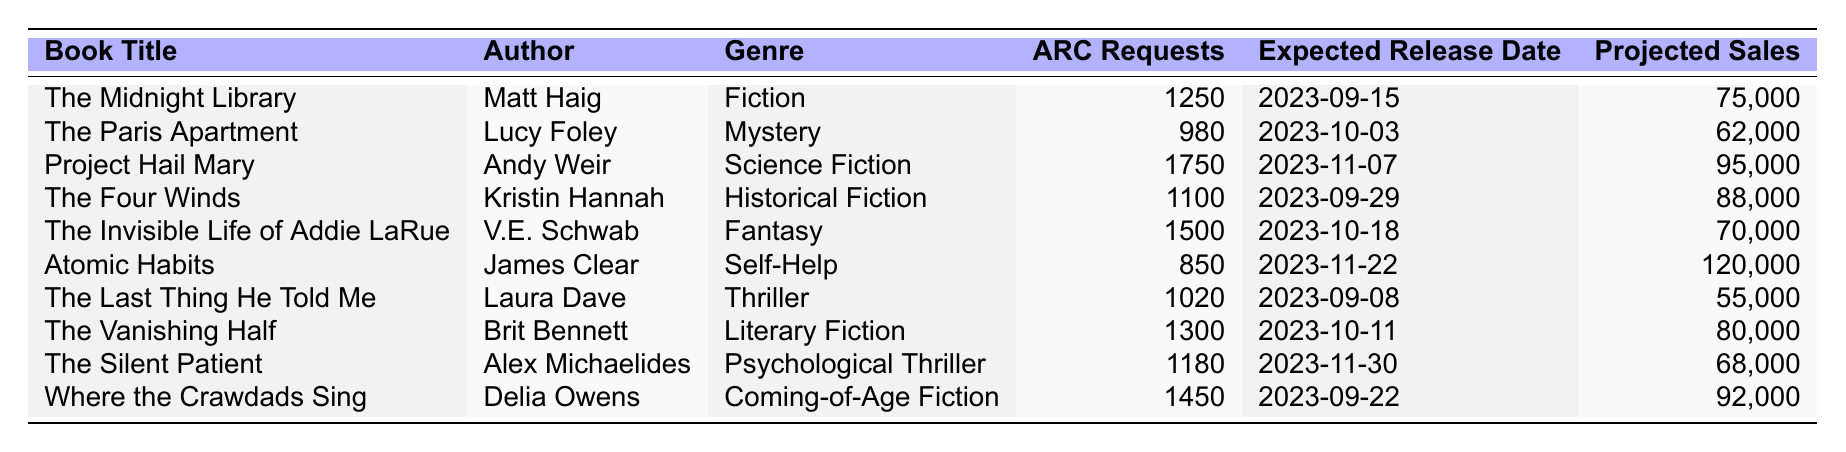What is the book with the highest ARC requests? The data shows the ARC requests for each book. "Project Hail Mary" has 1750 requests, which is higher than all other titles.
Answer: Project Hail Mary Which book is expected to have the earliest release date? Upon reviewing the release dates, "The Last Thing He Told Me" is set to be released on 2023-09-08, which is earlier than any other book in the table.
Answer: The Last Thing He Told Me How many ARC requests did "The Invisible Life of Addie LaRue" receive? The table lists 1500 ARC requests for "The Invisible Life of Addie LaRue".
Answer: 1500 Which genre has the highest total number of ARC requests? To find the total for each genre, sum the requests for each book in that genre: Fiction (1250), Mystery (980), Science Fiction (1750), Historical Fiction (1100), Fantasy (1500), Self-Help (850), Thriller (1020), Literary Fiction (1300), Psychological Thriller (1180), Coming-of-Age Fiction (1450). The highest total is for Science Fiction with 1750 requests.
Answer: Science Fiction Is "Atomic Habits" projected to sell more than 100,000 copies? The projected sales for "Atomic Habits" are stated as 120,000, which is indeed more than 100,000.
Answer: Yes What is the average number of ARC requests for all the books listed? First, list the ARC requests: 1250, 980, 1750, 1100, 1500, 850, 1020, 1300, 1180, 1450. Next, sum them to get 10380 and divide by 10 (the number of books) resulting in an average of 1038.
Answer: 1038 Which book's genre received exactly 1020 ARC requests? "The Last Thing He Told Me" is explicitly noted in the table as having received 1020 ARC requests.
Answer: The Last Thing He Told Me What is the difference in projected sales between the book with the least and the most sales? The least projected sales figure is 55,000 ("The Last Thing He Told Me") and the most is 120,000 ("Atomic Habits"). The difference is calculated as 120,000 - 55,000 = 65,000.
Answer: 65,000 Are there any Fantasy genre books that received more ARC requests than 1,000? "The Invisible Life of Addie LaRue" received 1500 ARC requests, which is indeed more than 1,000. Hence, the answer is affirmative.
Answer: Yes Which two books have an expected release date closest to each other? "The Vanishing Half" is expected on 2023-10-11 and "The Invisible Life of Addie LaRue" is on 2023-10-18. The difference is 7 days. Checking others, it's the least gap between the release dates after "The Last Thing He Told Me".
Answer: The Vanishing Half and The Invisible Life of Addie LaRue 